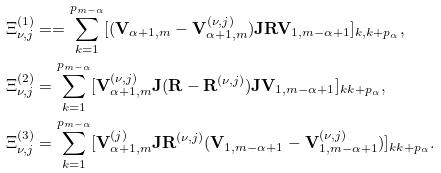<formula> <loc_0><loc_0><loc_500><loc_500>\Xi _ { \nu , j } ^ { ( 1 ) } & = = \sum _ { k = 1 } ^ { p _ { m - \alpha } } [ ( \mathbf V _ { \alpha + 1 , m } - \mathbf V _ { \alpha + 1 , m } ^ { ( \nu , j ) } ) \mathbf J \mathbf R \mathbf V _ { 1 , m - \alpha + 1 } ] _ { k , k + p _ { \alpha } } , \\ \Xi _ { \nu , j } ^ { ( 2 ) } & = \sum _ { k = 1 } ^ { p _ { m - \alpha } } [ \mathbf V _ { \alpha + 1 , m } ^ { ( \nu , j ) } \mathbf J ( \mathbf R - \mathbf R ^ { ( \nu , j ) } ) \mathbf J \mathbf V _ { 1 , m - \alpha + 1 } ] _ { k k + p _ { \alpha } } , \\ \Xi _ { \nu , j } ^ { ( 3 ) } & = \sum _ { k = 1 } ^ { p _ { m - \alpha } } [ \mathbf V ^ { ( j ) } _ { \alpha + 1 , m } \mathbf J \mathbf R ^ { ( \nu , j ) } ( \mathbf V _ { 1 , m - \alpha + 1 } - \mathbf V _ { 1 , m - \alpha + 1 } ^ { ( \nu , j ) } ) ] _ { k k + p _ { \alpha } } .</formula> 